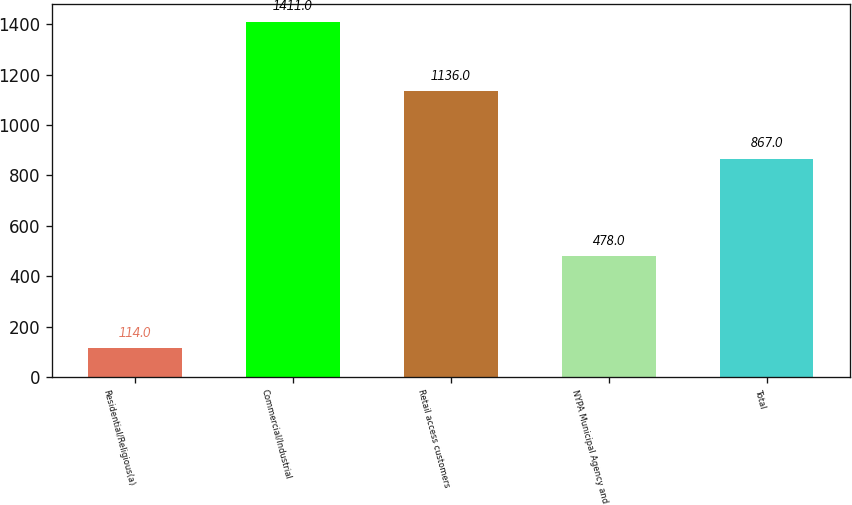<chart> <loc_0><loc_0><loc_500><loc_500><bar_chart><fcel>Residential/Religious(a)<fcel>Commercial/Industrial<fcel>Retail access customers<fcel>NYPA Municipal Agency and<fcel>Total<nl><fcel>114<fcel>1411<fcel>1136<fcel>478<fcel>867<nl></chart> 